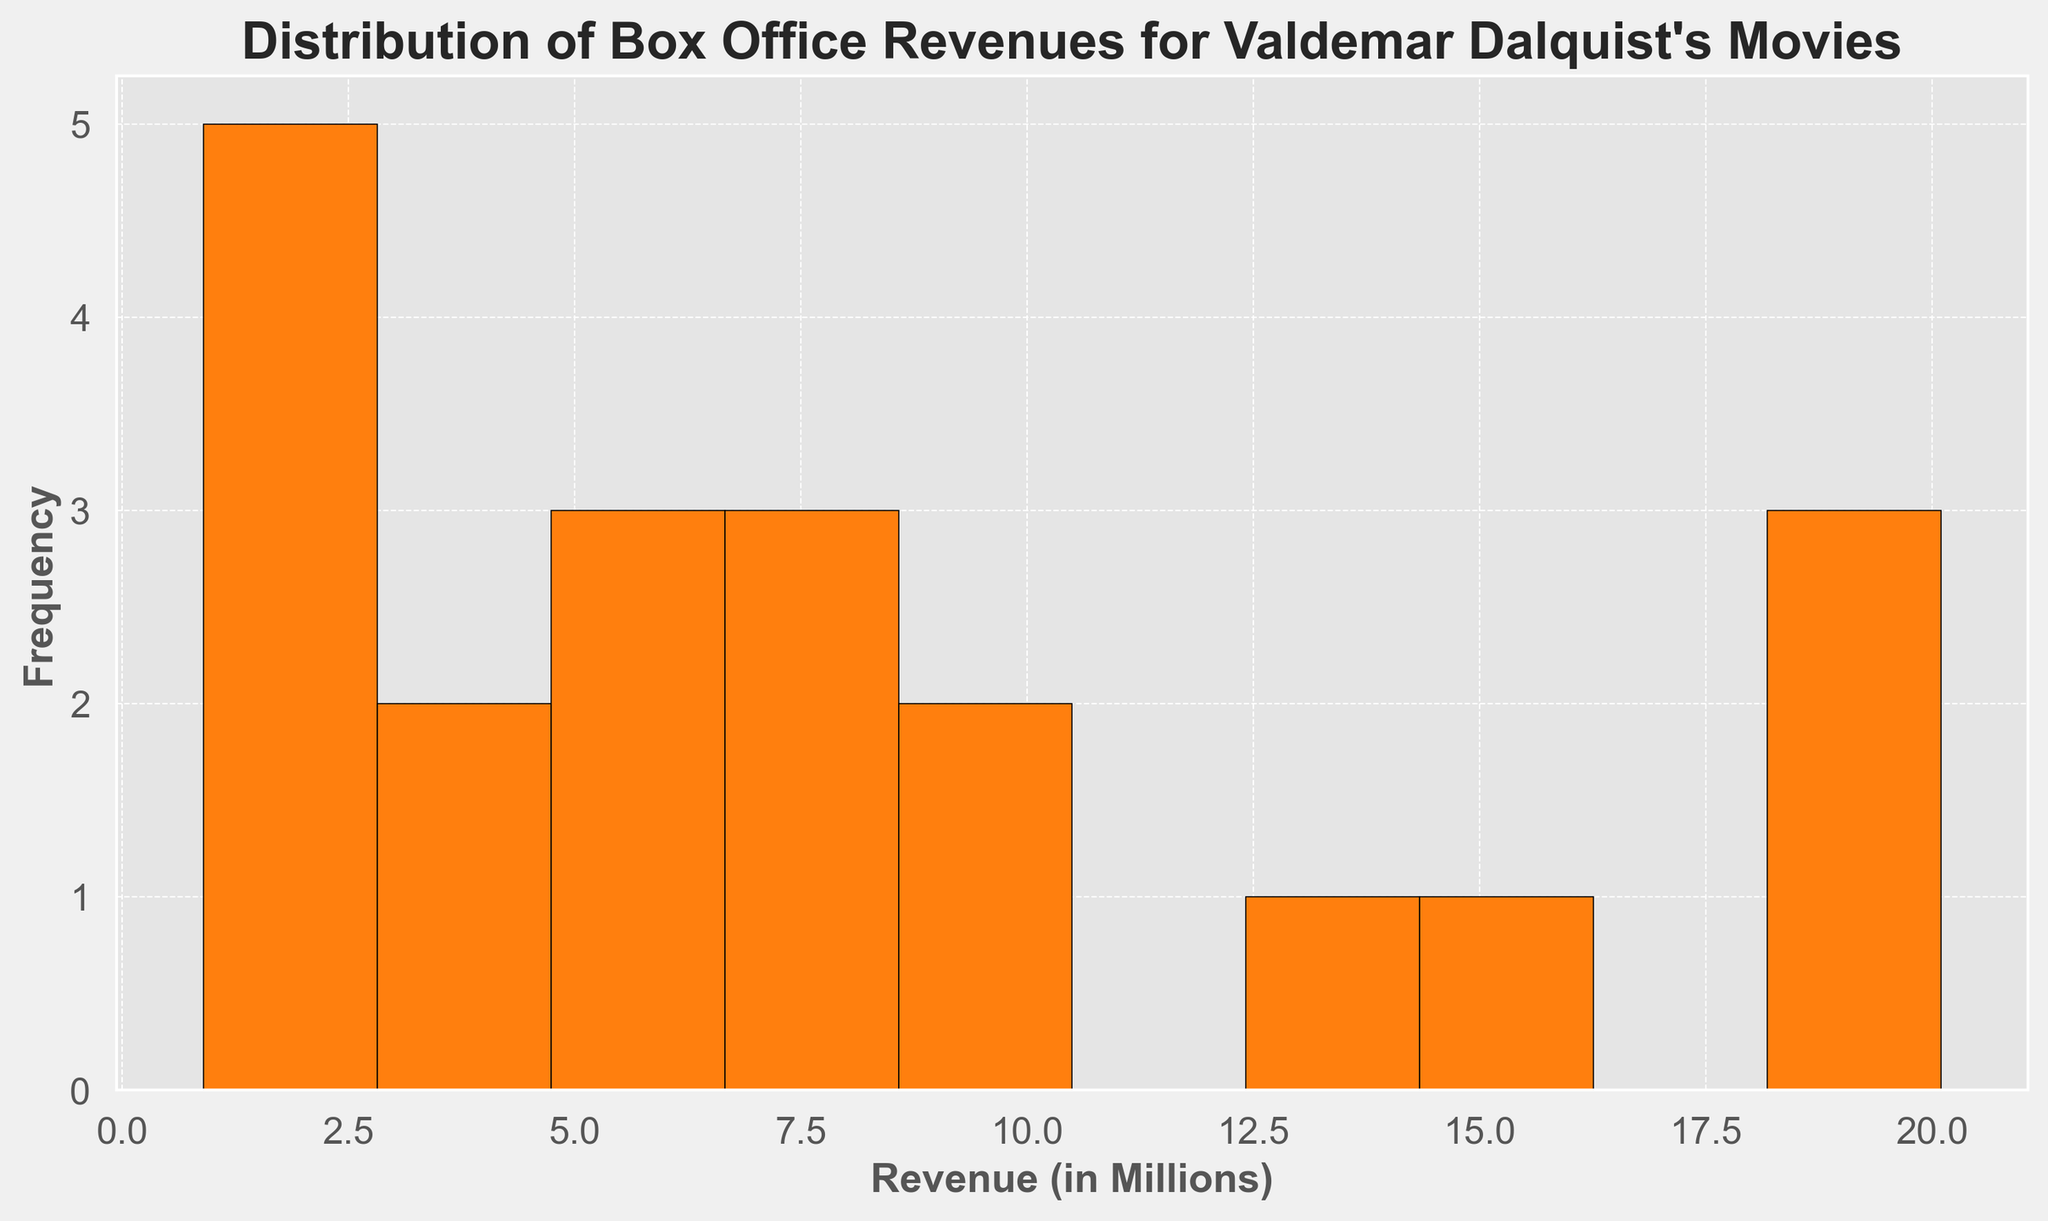What is the most common revenue range for Valdemar Dalquist's movies? By looking at the highest bar in the histogram, we can identify the revenue range with the highest frequency. This is the range that appears most often.
Answer: 1-3 million How many movies have a revenue of 10 million or more? We need to count the frequencies of all bars representing revenue ranges of 10 million and above. By summing these frequencies, we get the total count.
Answer: 6 Which revenue range has the least frequency and how many movies fall into this range? We will find the smallest bar in the histogram and identify its height. This represents the range with the fewest movies.
Answer: 15-17 million, 0 movies What is the average revenue for Valdemar Dalquist's movies? Sum all the movie revenues and divide by the total number of movies. Sum is 161.1 million and there are 20 movies. So, 161.1 / 20 = 8.055 million.
Answer: 8.055 million Which range has more movies: 4-6 million or 14-16 million? Compare the heights of the bars corresponding to the ranges 4-6 million and 14-16 million. The taller bar indicates which range has more movies.
Answer: 4-6 million Are there more movies with revenues less than 5 million or more than 15 million? Count the frequencies of the bars corresponding to revenues less than 5 million and those above 15 million. Compare these two counts.
Answer: Less than 5 million What is the median revenue for Valdemar Dalquist's movies? Arrange the revenues in ascending order. For 20 movies, the median will be the average of the 10th and 11th values in this ordered list. Adding the 10th and 11th values and dividing by 2 gives the median.
Answer: 6.15 million Is there a significant skew in the distribution of box office revenues? Explain. By analyzing the shape of the histogram, if most data is clustered on one side with a long tail on the other, it shows skewness. In this histogram, revenues are more frequent at lower values, with a tail extending to higher values, indicating positive skewness.
Answer: Positive skew How does the number of movies with revenues between 1-3 million compare to those with revenues between 7-9 million? Compare the heights of the bars in the 1-3 million range with those in the 7-9 million range to see which is taller, indicating more movies.
Answer: 1-3 million 